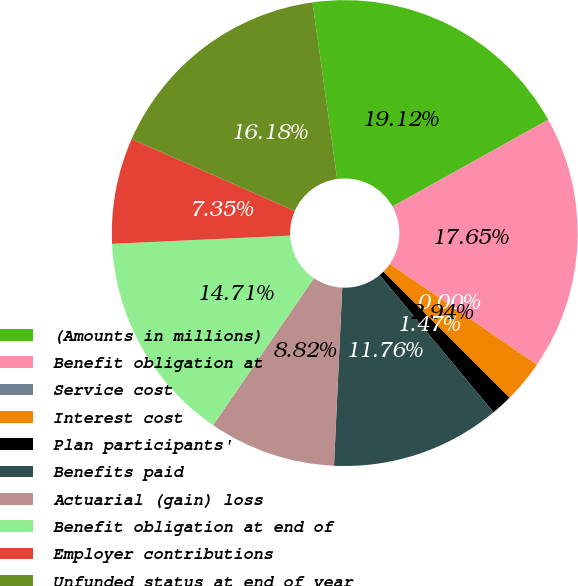Convert chart. <chart><loc_0><loc_0><loc_500><loc_500><pie_chart><fcel>(Amounts in millions)<fcel>Benefit obligation at<fcel>Service cost<fcel>Interest cost<fcel>Plan participants'<fcel>Benefits paid<fcel>Actuarial (gain) loss<fcel>Benefit obligation at end of<fcel>Employer contributions<fcel>Unfunded status at end of year<nl><fcel>19.11%<fcel>17.64%<fcel>0.0%<fcel>2.94%<fcel>1.47%<fcel>11.76%<fcel>8.82%<fcel>14.7%<fcel>7.35%<fcel>16.17%<nl></chart> 